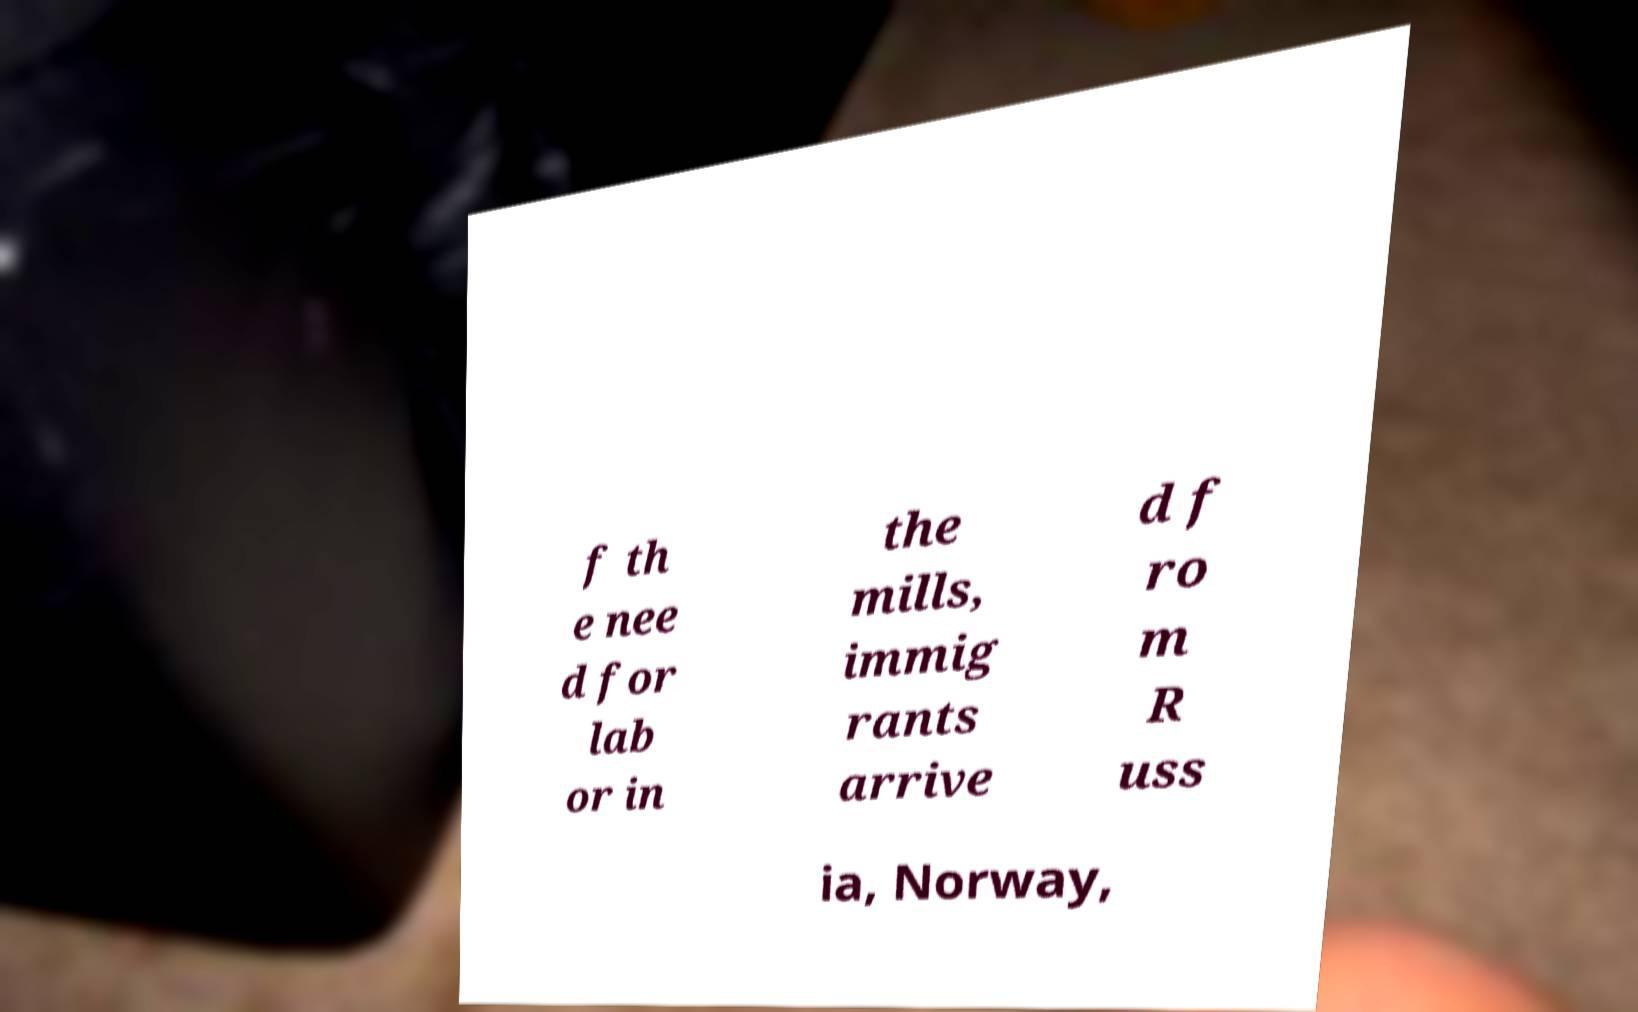Could you assist in decoding the text presented in this image and type it out clearly? f th e nee d for lab or in the mills, immig rants arrive d f ro m R uss ia, Norway, 